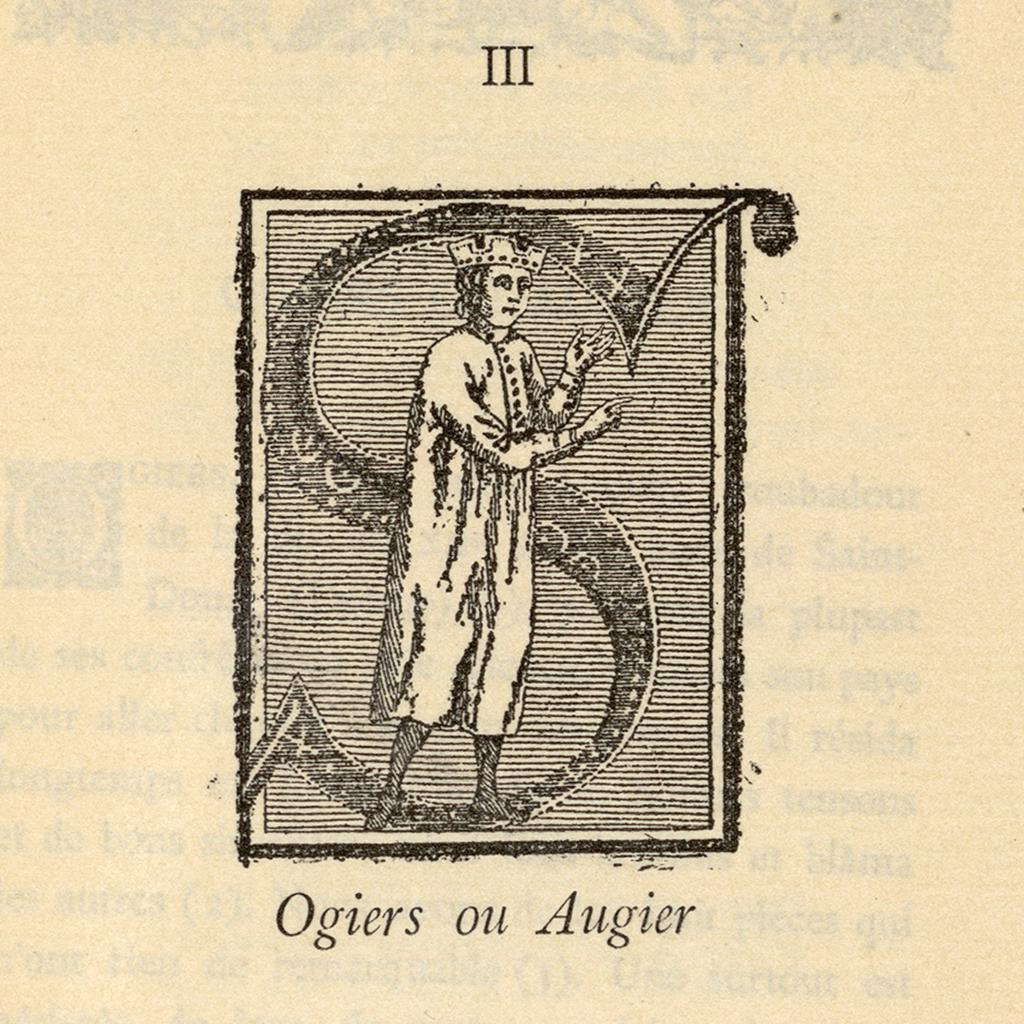What is the main subject of the image? There is a man standing in the image. Can you describe any text present in the image? Yes, there is writing at the top portion and the bottom portion of the image. What type of wave can be seen crashing on the shore in the image? There is no wave or shore present in the image; it features a man standing with writing at the top and bottom portions. 